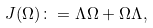Convert formula to latex. <formula><loc_0><loc_0><loc_500><loc_500>J ( \Omega ) \colon = \Lambda \Omega + \Omega \Lambda ,</formula> 